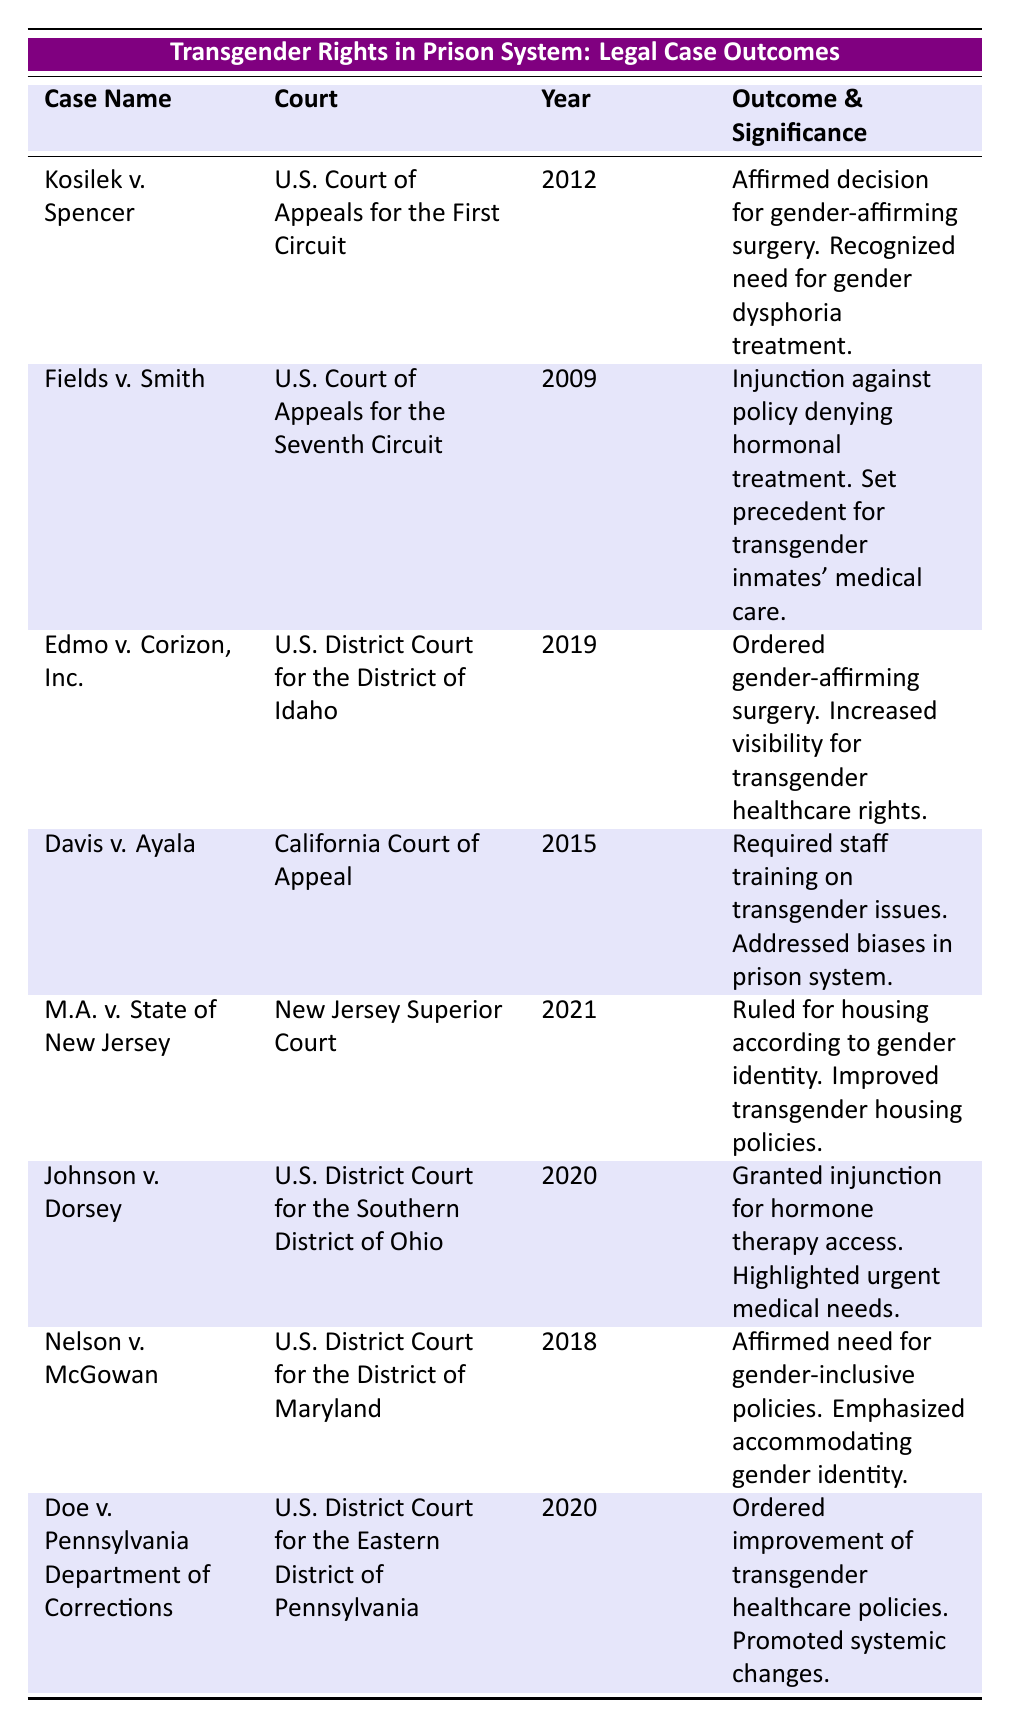What is the outcome of the case "Kosilek v. Spencer"? The table shows that the outcome of "Kosilek v. Spencer" is "Affirmed the lower court's decision for gender-affirming surgery."
Answer: Affirmed the lower court's decision for gender-affirming surgery Which court handled the case "Fields v. Smith"? According to the table, "Fields v. Smith" was handled by the "U.S. Court of Appeals for the Seventh Circuit."
Answer: U.S. Court of Appeals for the Seventh Circuit What year was the case "Edmo v. Corizon, Inc." decided? The table indicates that "Edmo v. Corizon, Inc." was decided in the year 2019.
Answer: 2019 Did the case "Davis v. Ayala" require staff training on transgender issues? The table states that "Davis v. Ayala" found in favor of the inmate, requiring staff training on transgender issues, thereby confirming that this was a requirement.
Answer: Yes How many cases in the table resulted in the requirement for healthcare related to gender dysphoria? The cases "Kosilek v. Spencer," "Fields v. Smith," "Edmo v. Corizon, Inc.," and "Johnson v. Dorsey" all are related to healthcare for gender dysphoria. That totals 4 cases.
Answer: 4 What is the significance of "M.A. v. State of New Jersey"? The significance noted in the table for "M.A. v. State of New Jersey" is that it led to improved policies regarding housing for transgender individuals.
Answer: Improved policies regarding housing Which case had the significance of promoting systemic changes within the healthcare system? The table indicates that "Doe v. Pennsylvania Department of Corrections" ordered improvements in transgender healthcare policies, thus promoting systemic changes.
Answer: Doe v. Pennsylvania Department of Corrections Which case from 2020 involved access to hormone therapy? The table shows that "Johnson v. Dorsey," decided in 2020, granted a preliminary injunction for access to hormone therapy.
Answer: Johnson v. Dorsey Which court ruled in favor of gender-inclusive policies? The table indicates that the "U.S. District Court for the District of Maryland," in the case "Nelson v. McGowan," affirmed the need for gender-inclusive policies.
Answer: U.S. District Court for the District of Maryland What total number of cases in the table occurred before 2015? Upon reviewing the table, cases "Fields v. Smith" (2009), "Cosilek v. Spencer" (2012), and "Davis v. Ayala" (2015) were found. This amounts to 3 cases.
Answer: 3 What were the outcomes of the two most recent cases in the table, by year? The two most recent cases are "M.A. v. State of New Jersey" (2021), which ruled that transgender inmates must be housed according to their gender identity, and "Doe v. Pennsylvania Department of Corrections" (2020), which ordered assessments to improve transgender healthcare policies.
Answer: "M.A. v. State of New Jersey": housing by gender identity; "Doe v. Pennsylvania Department of Corrections": improve healthcare policies 